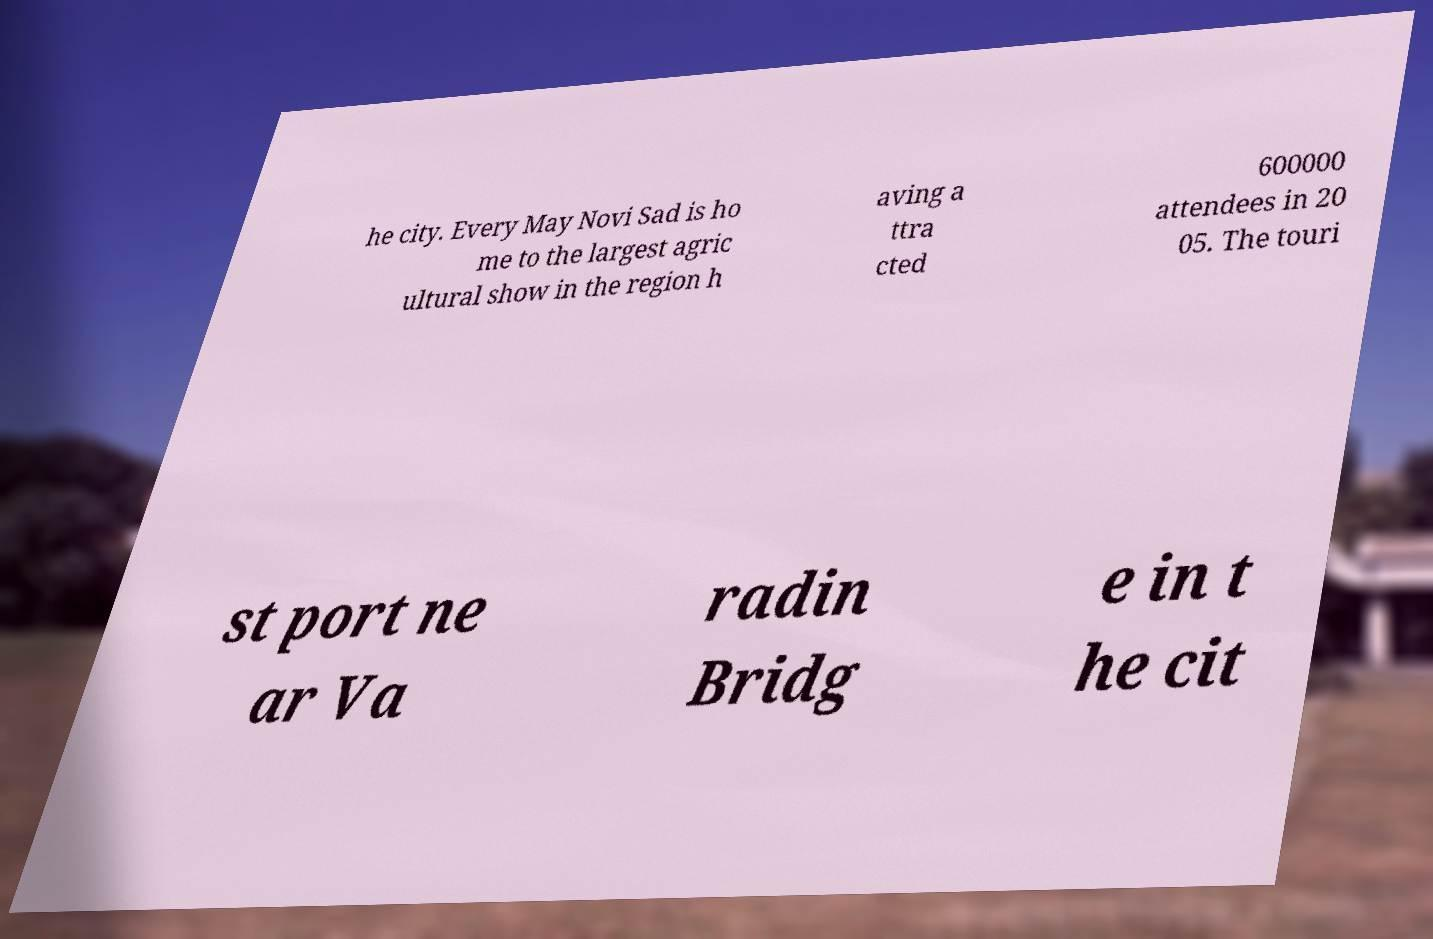Please identify and transcribe the text found in this image. he city. Every May Novi Sad is ho me to the largest agric ultural show in the region h aving a ttra cted 600000 attendees in 20 05. The touri st port ne ar Va radin Bridg e in t he cit 